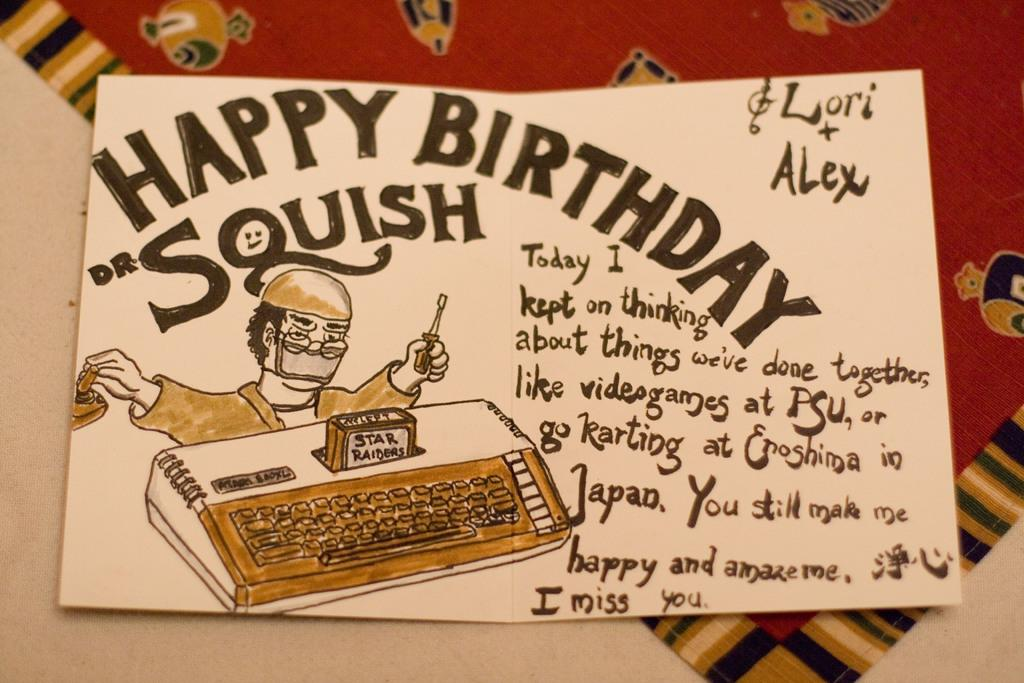<image>
Offer a succinct explanation of the picture presented. A hand drawn card that reads Happy Birthday Squish. 